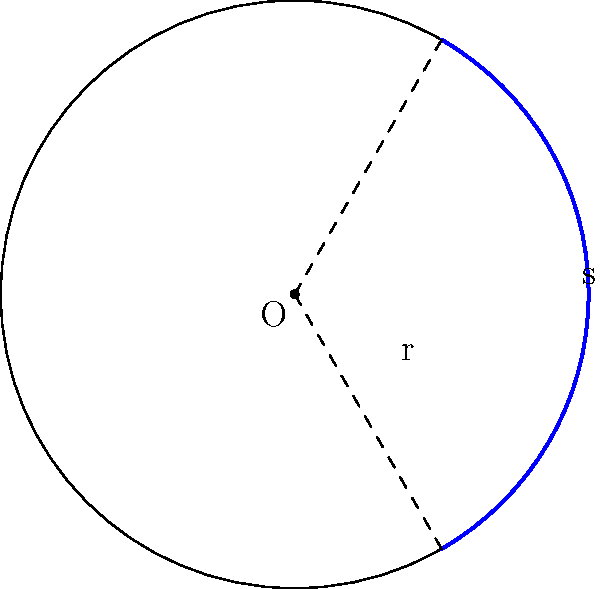As a professional kiteboarder, you're designing a circular course for a competition. The course has a radius of 150 meters, and the arc length that competitors must travel is 314 meters. What is the central angle, in degrees, that this arc subtends at the center of the circle? To find the central angle, we'll use the formula for arc length and solve for the angle. Let's approach this step-by-step:

1) The formula for arc length is:
   $s = r\theta$
   where $s$ is the arc length, $r$ is the radius, and $\theta$ is the central angle in radians.

2) We know:
   $s = 314$ meters
   $r = 150$ meters

3) Substituting these values into the formula:
   $314 = 150\theta$

4) Solving for $\theta$:
   $\theta = \frac{314}{150} = 2.0933$ radians

5) To convert radians to degrees, we multiply by $\frac{180}{\pi}$:
   $\theta_{degrees} = 2.0933 \times \frac{180}{\pi} = 120°$

Therefore, the central angle is approximately 120 degrees.
Answer: 120° 